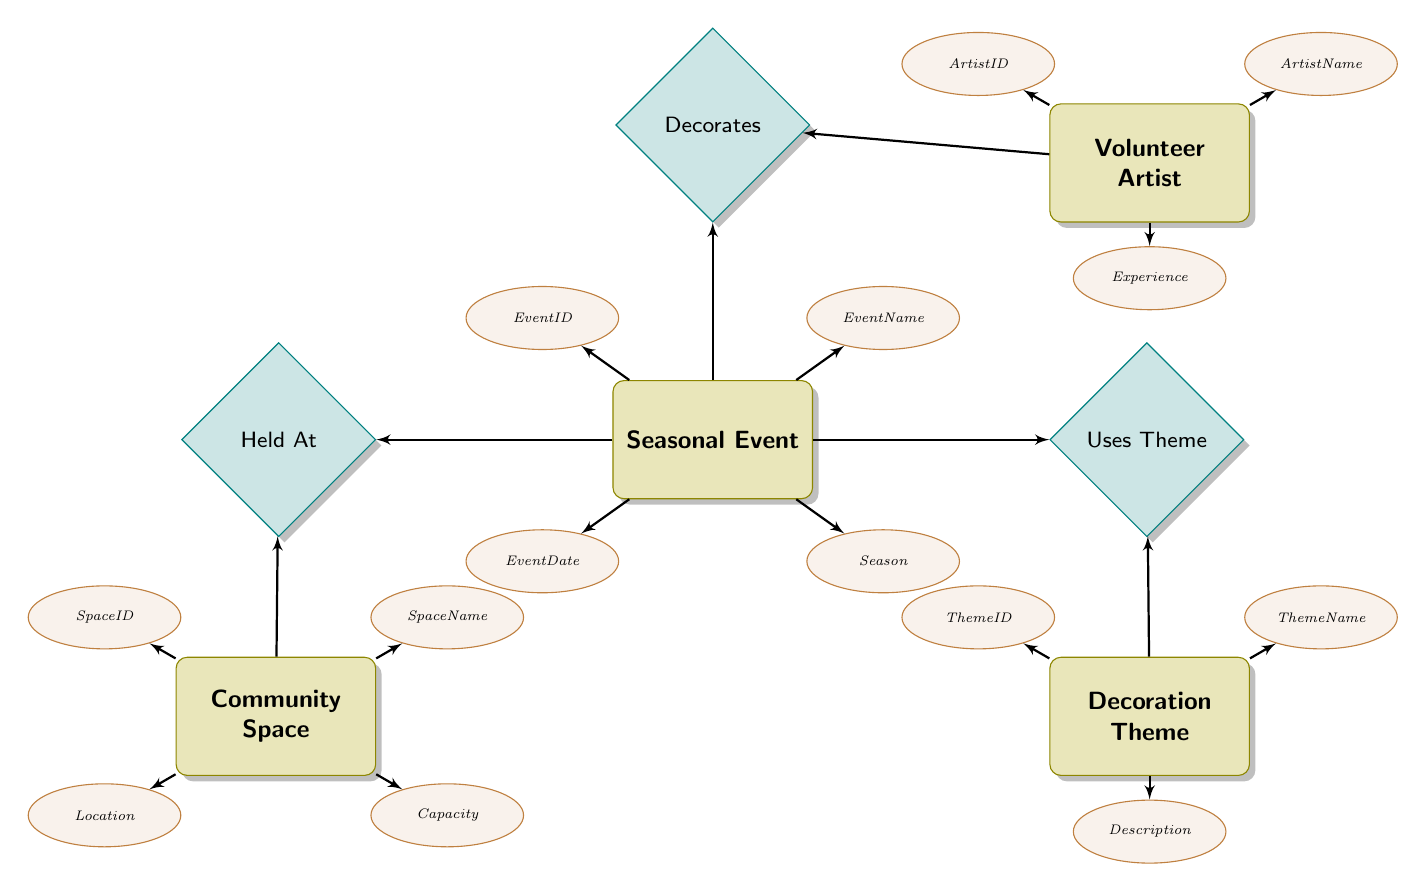What entity represents the seasonal activities? The entity labeled "Seasonal Event" clearly represents the various activities scheduled around specific seasons as it is the central node related to decoration themes and community spaces.
Answer: Seasonal Event How many attributes does the Volunteer Artist entity have? By examining the "Volunteer Artist" entity in the diagram, we see it has three listed attributes: ArtistID, ArtistName, and Experience. Counting these gives us a total of three attributes.
Answer: 3 What is the name of the relationship between Seasonal Event and Decoration Theme? The relationship depicted between these two entities is labeled as "Uses Theme," indicating how seasonal events utilize different decoration themes.
Answer: Uses Theme Which entity appears to be related to the largest number of other entities? The "Seasonal Event" entity connects with three other entities (Decoration Theme, Volunteer Artist, Community Space), making it the focal point of relationships and the most connected entity in the diagram.
Answer: Seasonal Event What attribute describes the physical location of events? The attribute indicating where events take place is found under the "Community Space" entity, specifically the attribute named "Location."
Answer: Location Describe how many relationships the Decoration Theme has. The "Decoration Theme" entity connects to other entities through a single relationship called "Uses Theme," which links it to the "Seasonal Event." Therefore, Decoration Theme has one direct relationship in the diagram.
Answer: 1 What is the purpose of the Held At relationship? The "Held At" relationship connects "Seasonal Event" with "Community Space" to indicate which community spaces events are booked and taking place, thereby defining the locations of occasions.
Answer: To indicate location What type of attribute is 'Description' in relation to the Decoration Theme? The 'Description' attribute, associated with the "Decoration Theme" entity, is categorized as an attribute since it provides additional details about the decoration theme style or characteristics.
Answer: Attribute What is the unique identifier for a Volunteer Artist? The unique identifier for the "Volunteer Artist" is "ArtistID," which serves to distinguish one artist from another within the records.
Answer: ArtistID 